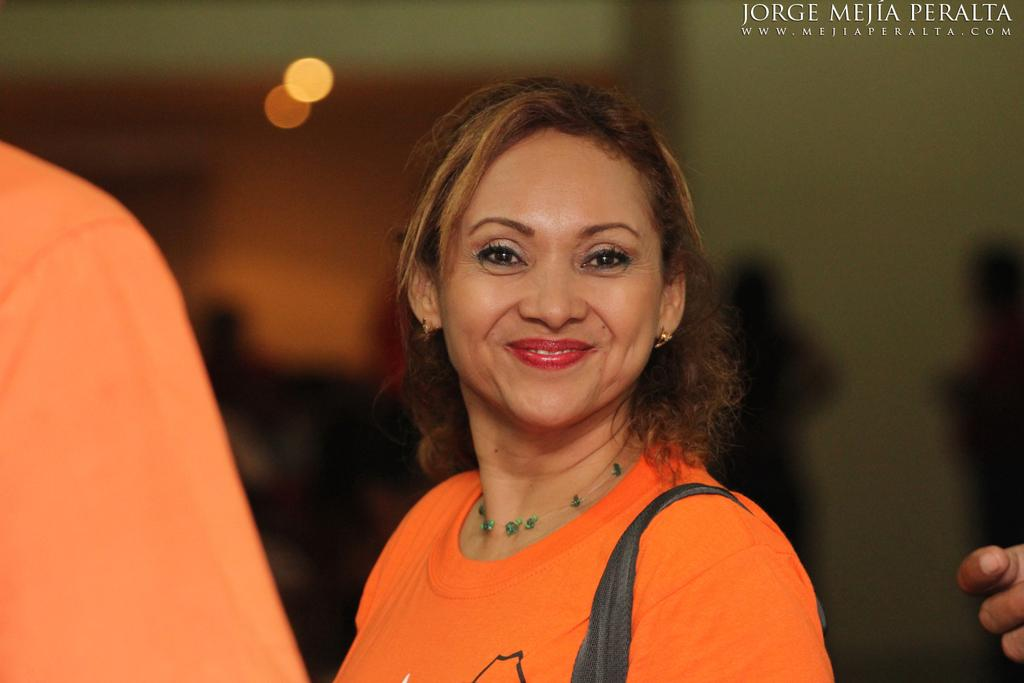Who is the main subject in the image? There is a woman in the image. What is the woman doing in the image? The woman is standing and smiling. Can you describe the background of the image? The background of the image is blurred. Is there any text visible in the image? Yes, there is some text visible at the top of the image. What type of game is the woman playing in the image? There is no game present in the image; the woman is simply standing and smiling. 